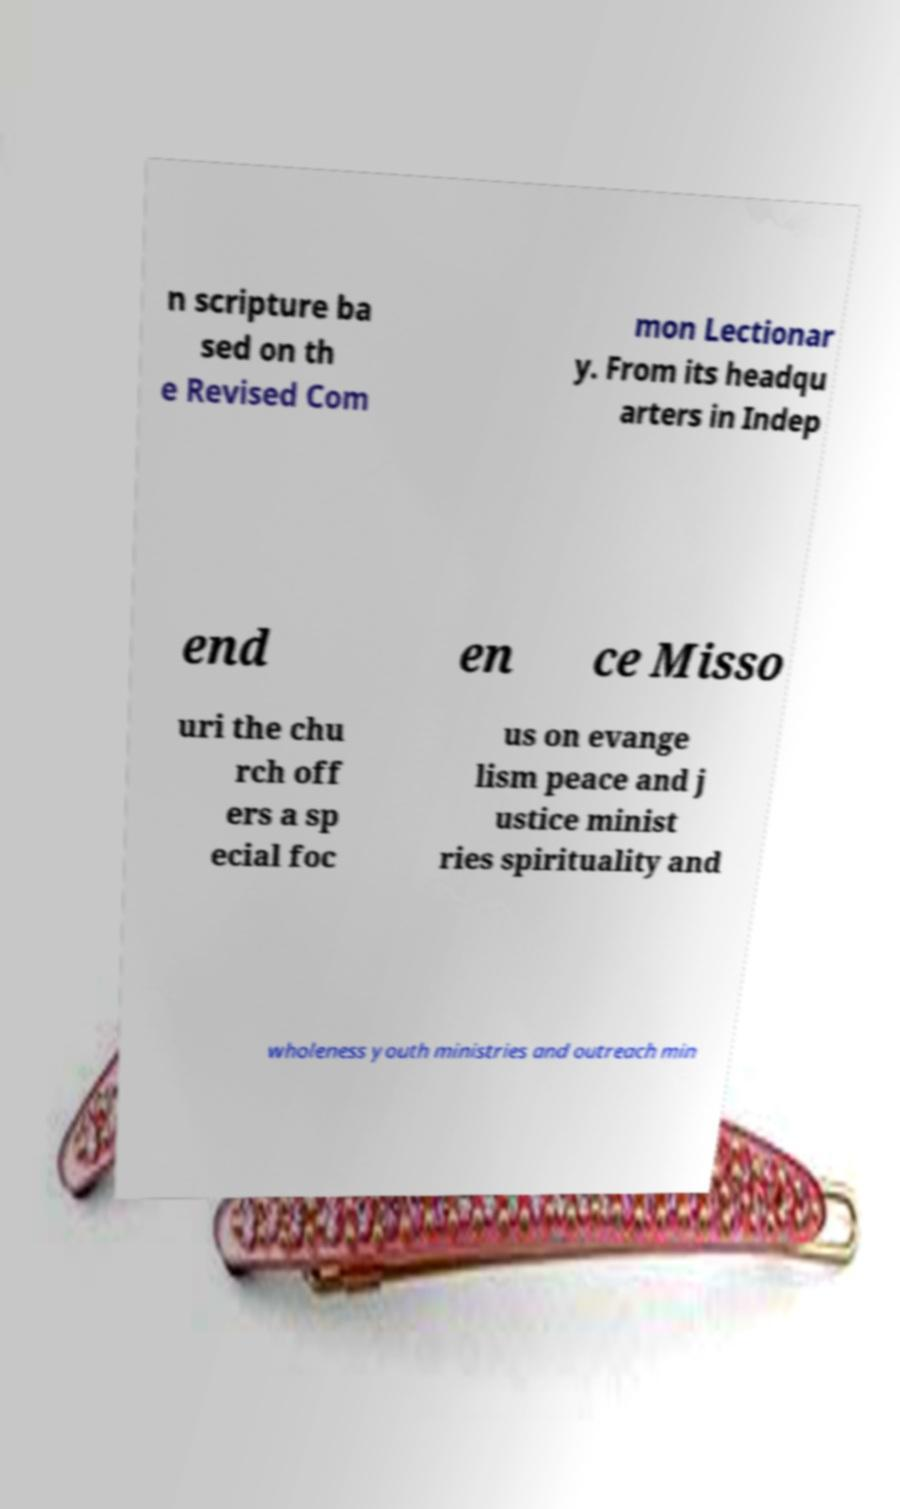Can you read and provide the text displayed in the image?This photo seems to have some interesting text. Can you extract and type it out for me? n scripture ba sed on th e Revised Com mon Lectionar y. From its headqu arters in Indep end en ce Misso uri the chu rch off ers a sp ecial foc us on evange lism peace and j ustice minist ries spirituality and wholeness youth ministries and outreach min 